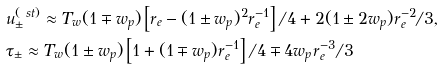Convert formula to latex. <formula><loc_0><loc_0><loc_500><loc_500>& u _ { \pm } ^ { ( \ s t ) } \approx T _ { w } ( 1 \mp w _ { p } ) \left [ r _ { e } - ( 1 \pm w _ { p } ) ^ { 2 } r _ { e } ^ { - 1 } \right ] / 4 + 2 ( 1 \pm 2 w _ { p } ) r _ { e } ^ { - 2 } / 3 , \\ & \tau _ { \pm } \approx T _ { w } ( 1 \pm w _ { p } ) \left [ 1 + ( 1 \mp w _ { p } ) r _ { e } ^ { - 1 } \right ] / 4 \mp 4 w _ { p } r _ { e } ^ { - 3 } / 3</formula> 